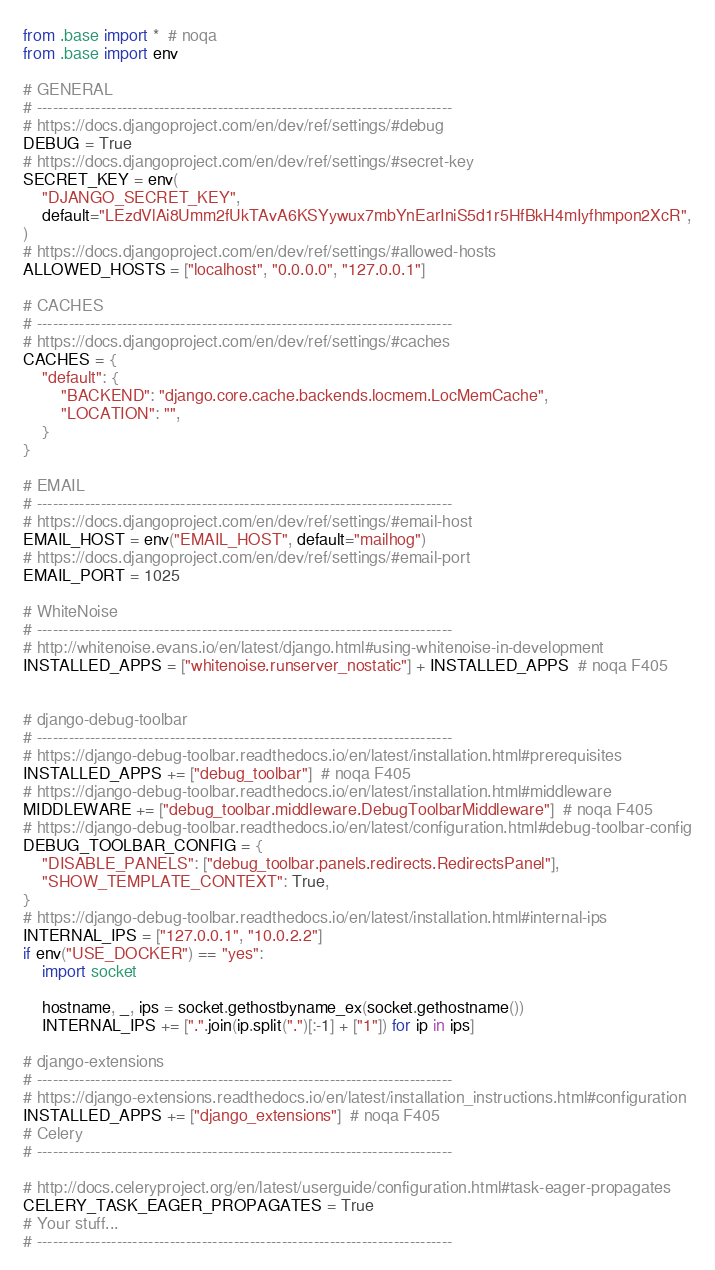<code> <loc_0><loc_0><loc_500><loc_500><_Python_>from .base import *  # noqa
from .base import env

# GENERAL
# ------------------------------------------------------------------------------
# https://docs.djangoproject.com/en/dev/ref/settings/#debug
DEBUG = True
# https://docs.djangoproject.com/en/dev/ref/settings/#secret-key
SECRET_KEY = env(
    "DJANGO_SECRET_KEY",
    default="LEzdVlAi8Umm2fUkTAvA6KSYywux7mbYnEarIniS5d1r5HfBkH4mIyfhmpon2XcR",
)
# https://docs.djangoproject.com/en/dev/ref/settings/#allowed-hosts
ALLOWED_HOSTS = ["localhost", "0.0.0.0", "127.0.0.1"]

# CACHES
# ------------------------------------------------------------------------------
# https://docs.djangoproject.com/en/dev/ref/settings/#caches
CACHES = {
    "default": {
        "BACKEND": "django.core.cache.backends.locmem.LocMemCache",
        "LOCATION": "",
    }
}

# EMAIL
# ------------------------------------------------------------------------------
# https://docs.djangoproject.com/en/dev/ref/settings/#email-host
EMAIL_HOST = env("EMAIL_HOST", default="mailhog")
# https://docs.djangoproject.com/en/dev/ref/settings/#email-port
EMAIL_PORT = 1025

# WhiteNoise
# ------------------------------------------------------------------------------
# http://whitenoise.evans.io/en/latest/django.html#using-whitenoise-in-development
INSTALLED_APPS = ["whitenoise.runserver_nostatic"] + INSTALLED_APPS  # noqa F405


# django-debug-toolbar
# ------------------------------------------------------------------------------
# https://django-debug-toolbar.readthedocs.io/en/latest/installation.html#prerequisites
INSTALLED_APPS += ["debug_toolbar"]  # noqa F405
# https://django-debug-toolbar.readthedocs.io/en/latest/installation.html#middleware
MIDDLEWARE += ["debug_toolbar.middleware.DebugToolbarMiddleware"]  # noqa F405
# https://django-debug-toolbar.readthedocs.io/en/latest/configuration.html#debug-toolbar-config
DEBUG_TOOLBAR_CONFIG = {
    "DISABLE_PANELS": ["debug_toolbar.panels.redirects.RedirectsPanel"],
    "SHOW_TEMPLATE_CONTEXT": True,
}
# https://django-debug-toolbar.readthedocs.io/en/latest/installation.html#internal-ips
INTERNAL_IPS = ["127.0.0.1", "10.0.2.2"]
if env("USE_DOCKER") == "yes":
    import socket

    hostname, _, ips = socket.gethostbyname_ex(socket.gethostname())
    INTERNAL_IPS += [".".join(ip.split(".")[:-1] + ["1"]) for ip in ips]

# django-extensions
# ------------------------------------------------------------------------------
# https://django-extensions.readthedocs.io/en/latest/installation_instructions.html#configuration
INSTALLED_APPS += ["django_extensions"]  # noqa F405
# Celery
# ------------------------------------------------------------------------------

# http://docs.celeryproject.org/en/latest/userguide/configuration.html#task-eager-propagates
CELERY_TASK_EAGER_PROPAGATES = True
# Your stuff...
# ------------------------------------------------------------------------------
</code> 